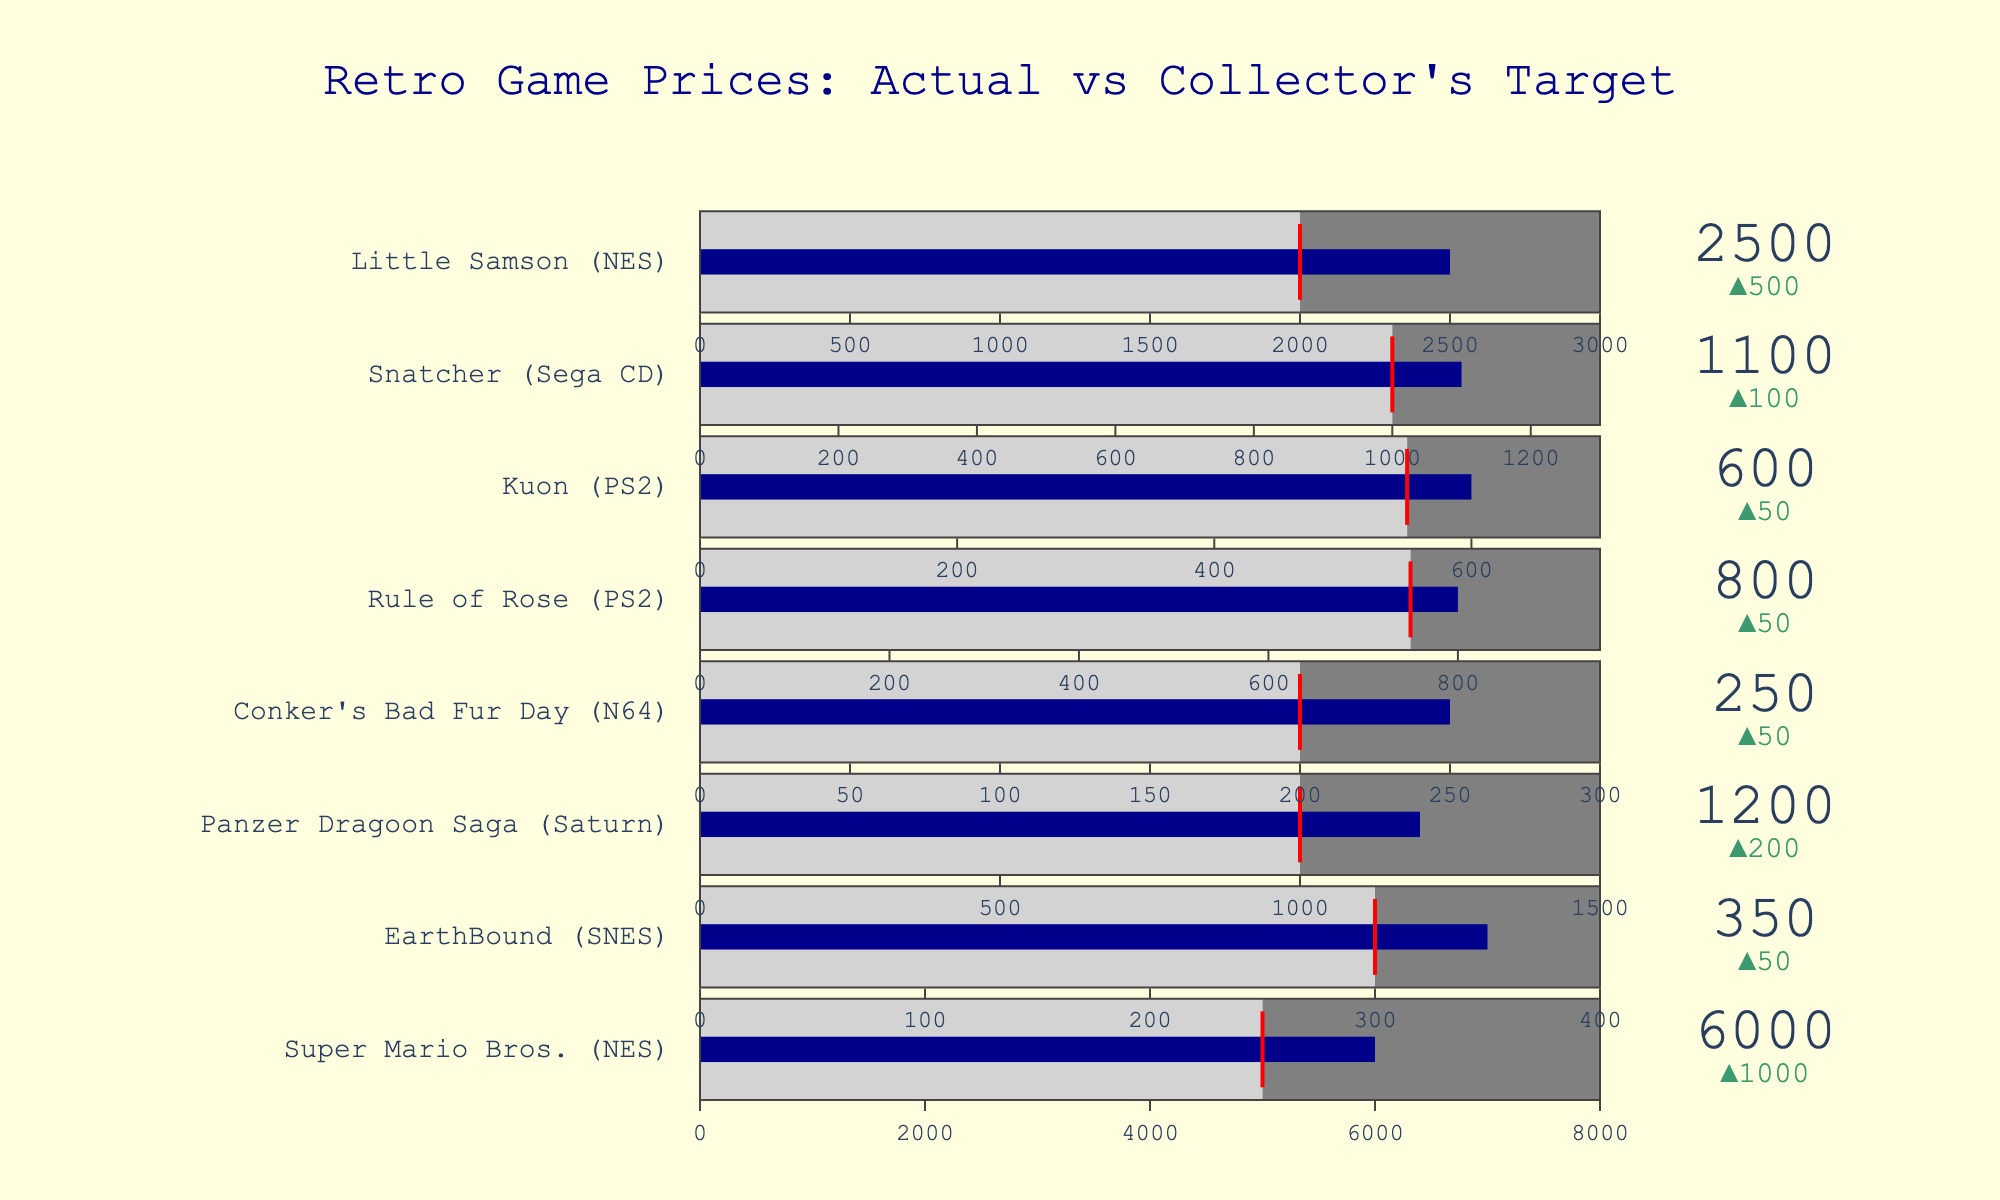what is the title of the figure? The title is generally the text that describes the main topic of the chart and is often found at the top. In this figure, the title is clearly written at the top-center.
Answer: Retro Game Prices: Actual vs Collector's Target how many data points are there in the chart? Data points correspond to the number of different retro games evaluated on the chart. Each title represents a unique data point. By counting the game titles listed on the chart, we know there are eight data points.
Answer: 8 what is the actual price of snatcher (sega cd)? The actual price is represented by the bullet mark in the chart. By finding "Snatcher (Sega CD)" in the chart, you can observe the actual price next to the gauge, indicated as 1100.
Answer: 1100 which game has the highest collector's value target? To find this out, you compare the collector's value targets indicated by the red lines for each game. Identify the highest value among all the games. "Super Mario Bros. (NES)" has the highest target, which is 5000.
Answer: Super Mario Bros. (NES) which game has the closest actual price to its collector's value target? To answer this, identify the games where the difference between the actual price and the collector's value target is the smallest. By visual inspection, the closest difference seems to belong to "Rule of Rose (PS2)". Actual Price: 800, Target: 750, Difference: 50.
Answer: Rule of Rose (PS2) what game has the largest deviation of actual price from its collector's value target? You need to find out the largest gap between the actual price and the collector's value target. The title with the noticeable difference is "Super Mario Bros. (NES)" where the actual price is 6000 and the collector's value target is 5000. The deviation is 1000.
Answer: Super Mario Bros. (NES) which game has the smallest market max value? The market max value refers to the maximum price range indicated for each game. "EarthBound (SNES)" has the smallest market max value at 400.
Answer: EarthBound (SNES) what is the total market max value of all nes games on the chart? To find the answer, add the market max values of all NES games. There are two NES games: "Super Mario Bros. (NES)" with a market max of 8000, and "Little Samson (NES)" with a market max of 3000. The total is 8000 + 3000 = 11000.
Answer: 11000 which retro game has an actual price exceeding its collector's value target by the greatest percentage? Calculate the percentage difference between actual price and collector's value target for each title. Percentage = ((actual price - collector's value target) / collector's value target) * 100. The game with the greatest percentage is "Super Mario Bros. (NES)": ((6000 - 5000) / 5000) * 100 = 20%.
Answer: Super Mario Bros. (NES) what is the average actual price of the games with a collector's value target of 1000? Identify games with a collector's value target of 1000 and calculate the average actual price: "Panzer Dragoon Saga (Saturn)" (Actual Price: 1200) and "Snatcher (Sega CD)" (Actual Price: 1100). Average = (1200 + 1100) / 2 = 1150.
Answer: 1150 